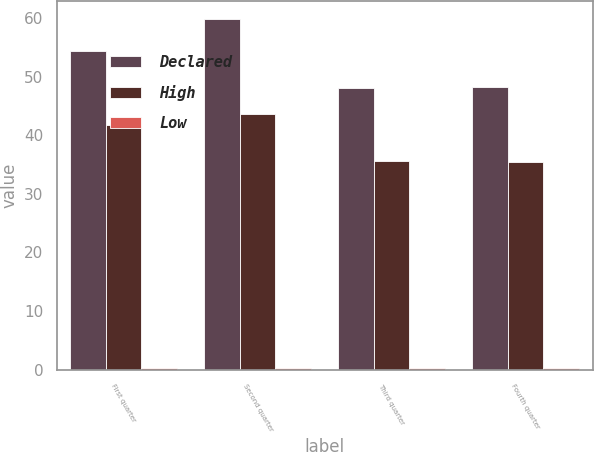Convert chart to OTSL. <chart><loc_0><loc_0><loc_500><loc_500><stacked_bar_chart><ecel><fcel>First quarter<fcel>Second quarter<fcel>Third quarter<fcel>Fourth quarter<nl><fcel>Declared<fcel>54.36<fcel>59.9<fcel>48.04<fcel>48.26<nl><fcel>High<fcel>41.8<fcel>43.6<fcel>35.61<fcel>35.4<nl><fcel>Low<fcel>0.25<fcel>0.25<fcel>0.25<fcel>0.25<nl></chart> 